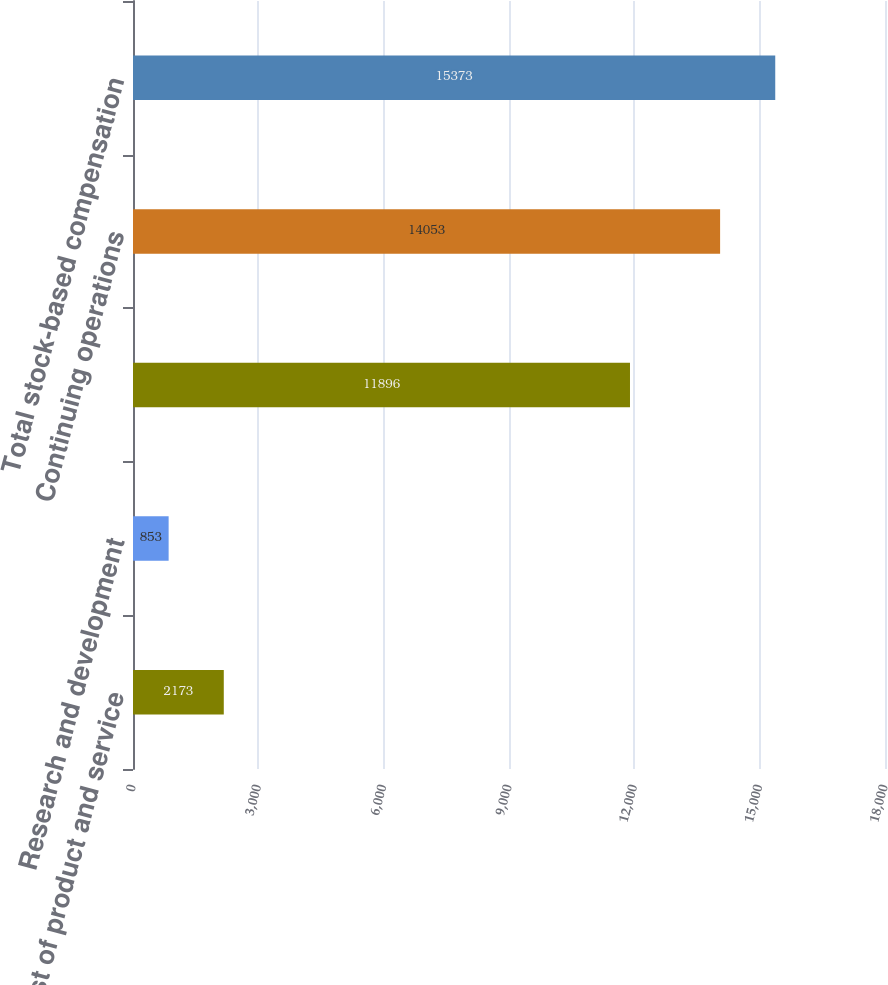<chart> <loc_0><loc_0><loc_500><loc_500><bar_chart><fcel>Cost of product and service<fcel>Research and development<fcel>Unnamed: 2<fcel>Continuing operations<fcel>Total stock-based compensation<nl><fcel>2173<fcel>853<fcel>11896<fcel>14053<fcel>15373<nl></chart> 